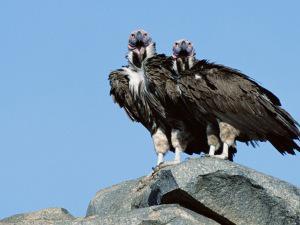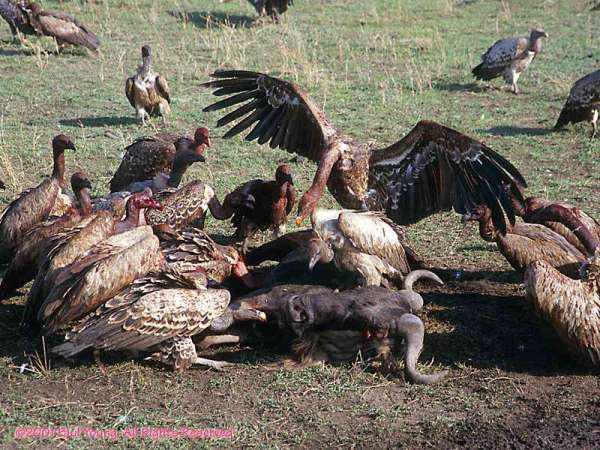The first image is the image on the left, the second image is the image on the right. Examine the images to the left and right. Is the description "An image shows exactly two vultures with sky-blue background." accurate? Answer yes or no. Yes. The first image is the image on the left, the second image is the image on the right. Evaluate the accuracy of this statement regarding the images: "One of the images shows exactly two birds.". Is it true? Answer yes or no. Yes. 